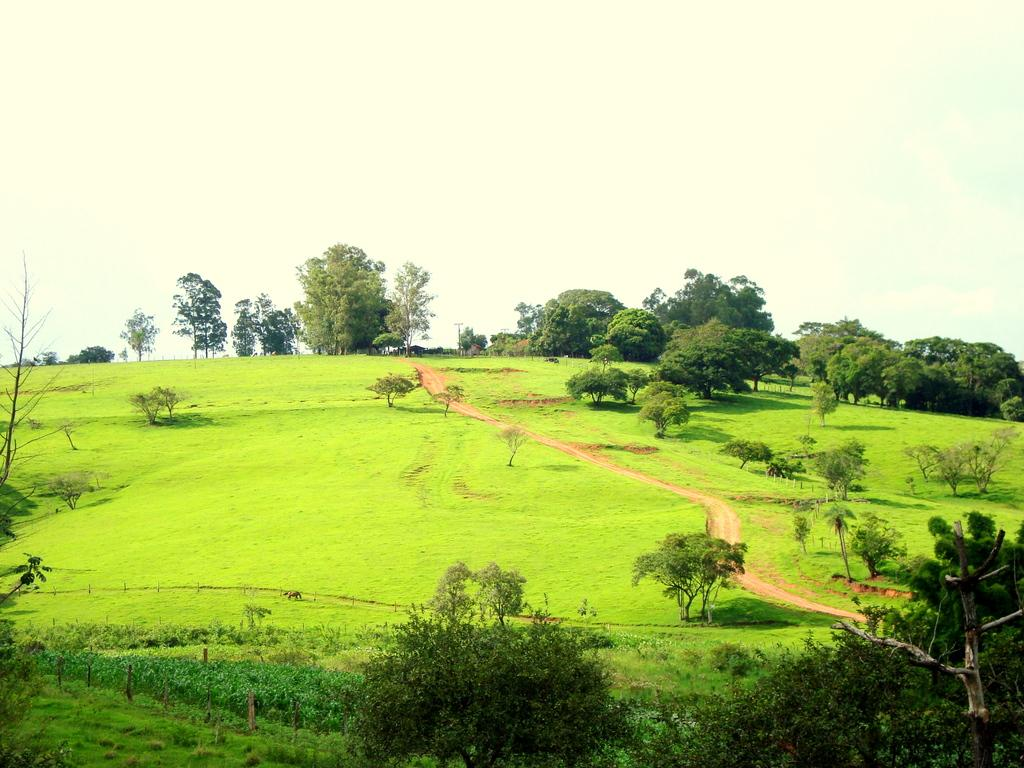What type of vegetation can be seen in the image? There are green trees in the image. What else can be seen in the image besides the trees? There are poles and green grass visible in the image. What is the color of the sky in the image? The sky is white in color. What type of honey is being served for dinner in the image? There is no honey or dinner present in the image; it features green trees, poles, green grass, and a white sky. What causes the shock in the image? There is no shock or indication of any electrical activity in the image. 